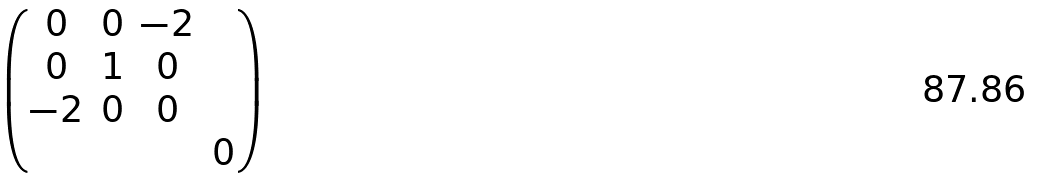Convert formula to latex. <formula><loc_0><loc_0><loc_500><loc_500>\begin{pmatrix} 0 & 0 & - 2 & \\ 0 & 1 & 0 & \\ - 2 & 0 & 0 & \\ & & & 0 \end{pmatrix}</formula> 